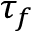Convert formula to latex. <formula><loc_0><loc_0><loc_500><loc_500>\tau _ { f }</formula> 